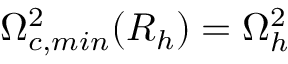<formula> <loc_0><loc_0><loc_500><loc_500>\Omega _ { c , \min } ^ { 2 } ( R _ { h } ) = \Omega _ { h } ^ { 2 }</formula> 